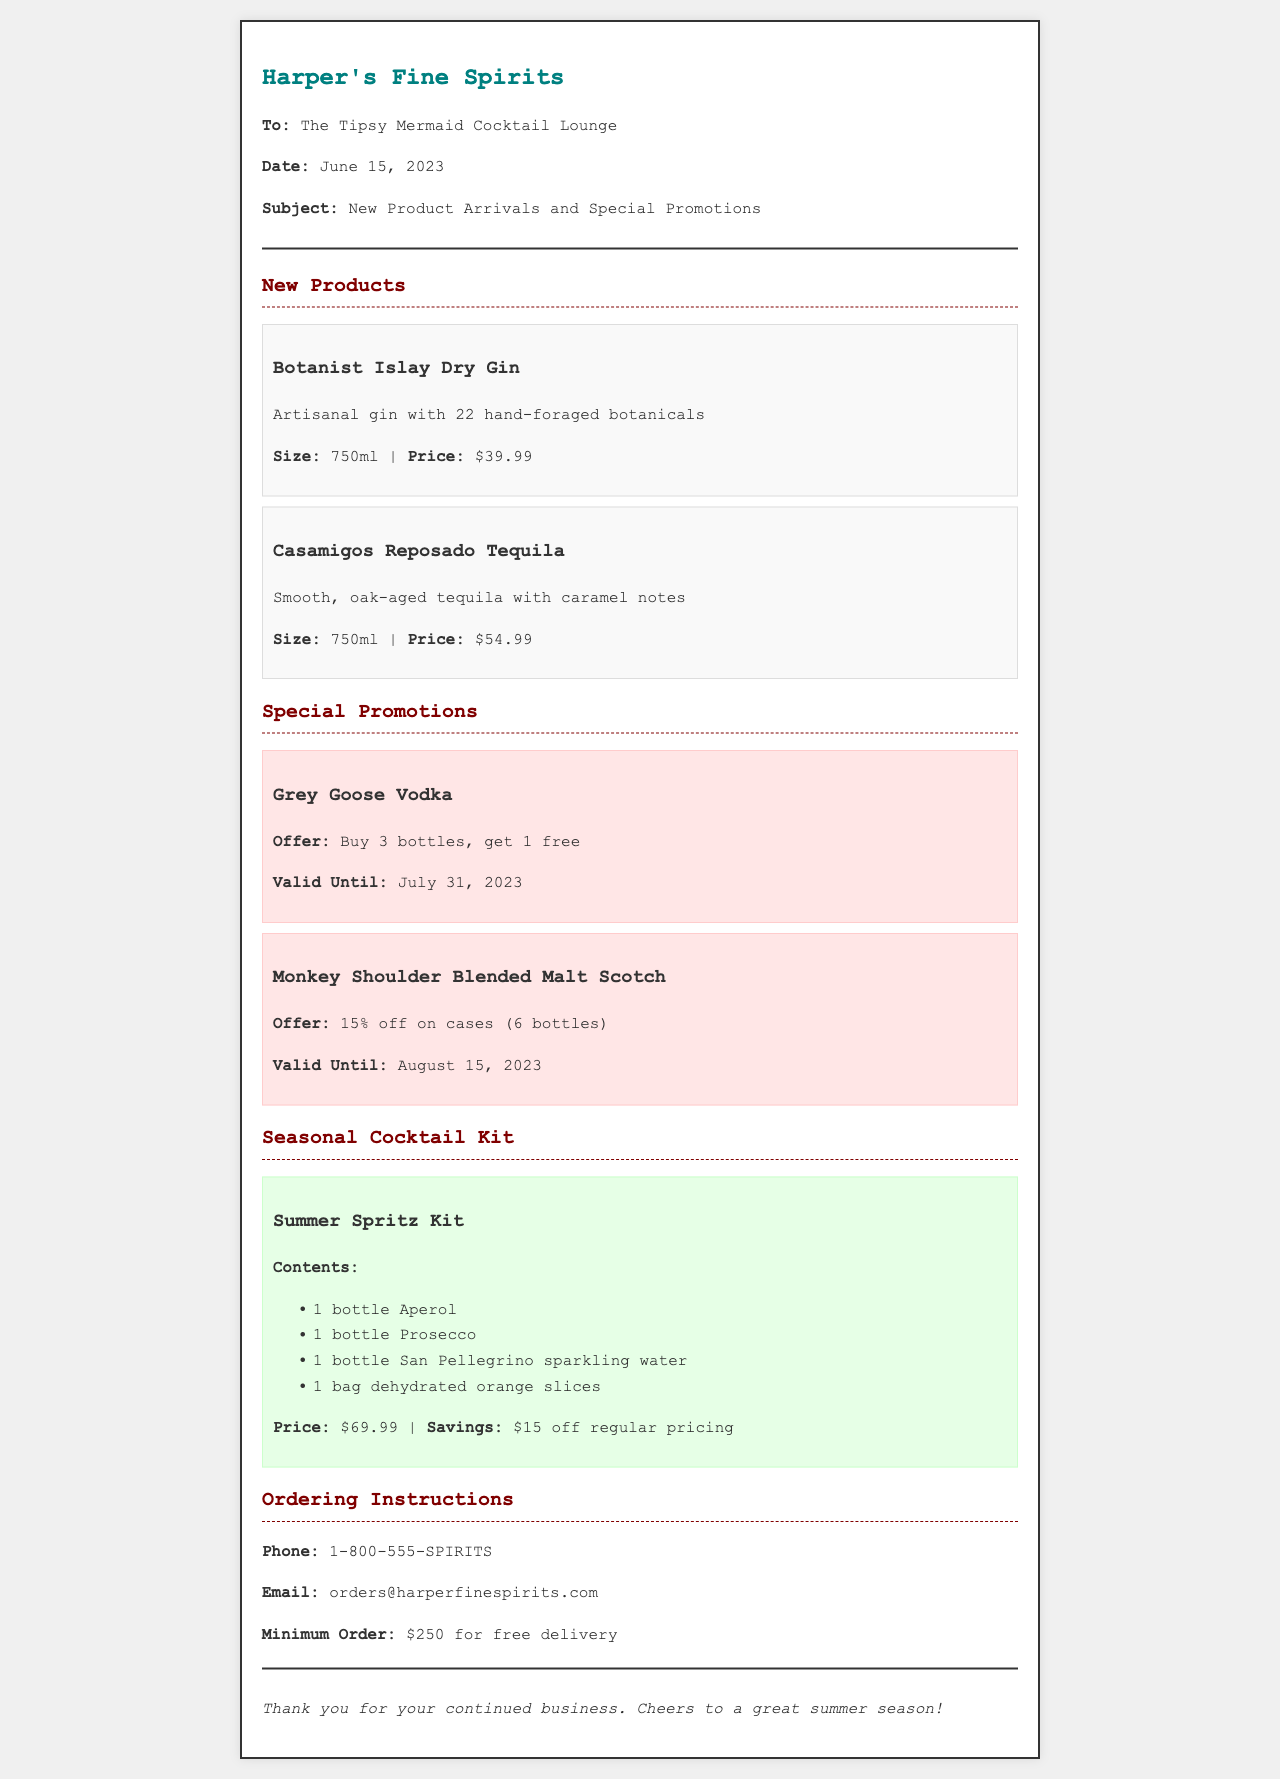What is the date of the fax? The date provided in the fax document is located in the header section, which states June 15, 2023.
Answer: June 15, 2023 What is the price of Botanist Islay Dry Gin? The price is mentioned in the product section under Botanist Islay Dry Gin, which is $39.99.
Answer: $39.99 What is the offer for Grey Goose Vodka? The offer is detailed in the special promotions section, stating that if you buy 3 bottles, you get 1 free.
Answer: Buy 3 bottles, get 1 free How long is the Monkey Shoulder Blended Malt Scotch promotion valid? The validity period for the promotion can be found in the promotion section, which states it is valid until August 15, 2023.
Answer: August 15, 2023 What is included in the Summer Spritz Kit? The contents of the Summer Spritz Kit are listed in the seasonal cocktail kit section, specifically detailing the items included.
Answer: Aperol, Prosecco, San Pellegrino sparkling water, dehydrated orange slices What is the minimum order amount for free delivery? This information is located in the ordering instructions section, indicating the minimum order for free delivery is $250.
Answer: $250 What is the savings amount for the Summer Spritz Kit? The savings are mentioned in the seasonal cocktail kit section, stating there is a discount of $15 off regular pricing.
Answer: $15 What is the phone number for ordering? The ordering instructions provide this information clearly, stating the phone number is 1-800-555-SPIRITS.
Answer: 1-800-555-SPIRITS Who is the fax addressed to? The recipient is identified in the header of the fax, which specifies the fax is addressed to The Tipsy Mermaid Cocktail Lounge.
Answer: The Tipsy Mermaid Cocktail Lounge 